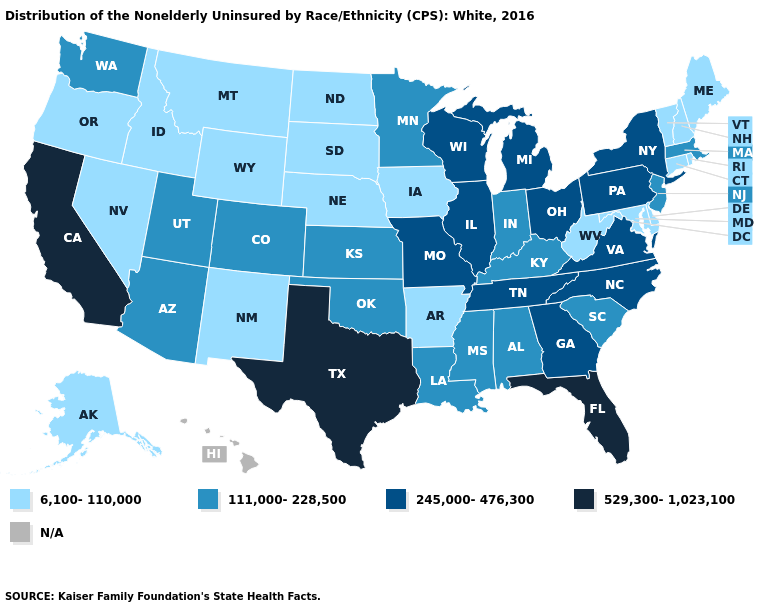What is the lowest value in the Northeast?
Give a very brief answer. 6,100-110,000. Name the states that have a value in the range 245,000-476,300?
Concise answer only. Georgia, Illinois, Michigan, Missouri, New York, North Carolina, Ohio, Pennsylvania, Tennessee, Virginia, Wisconsin. Among the states that border South Dakota , does Minnesota have the lowest value?
Give a very brief answer. No. Among the states that border Wisconsin , does Michigan have the lowest value?
Quick response, please. No. What is the value of Indiana?
Short answer required. 111,000-228,500. Does Florida have the highest value in the USA?
Keep it brief. Yes. Name the states that have a value in the range 529,300-1,023,100?
Concise answer only. California, Florida, Texas. Name the states that have a value in the range 111,000-228,500?
Keep it brief. Alabama, Arizona, Colorado, Indiana, Kansas, Kentucky, Louisiana, Massachusetts, Minnesota, Mississippi, New Jersey, Oklahoma, South Carolina, Utah, Washington. What is the highest value in the South ?
Give a very brief answer. 529,300-1,023,100. Name the states that have a value in the range 245,000-476,300?
Answer briefly. Georgia, Illinois, Michigan, Missouri, New York, North Carolina, Ohio, Pennsylvania, Tennessee, Virginia, Wisconsin. What is the value of Oklahoma?
Concise answer only. 111,000-228,500. What is the highest value in states that border Kansas?
Be succinct. 245,000-476,300. What is the highest value in states that border Arkansas?
Answer briefly. 529,300-1,023,100. What is the lowest value in the USA?
Write a very short answer. 6,100-110,000. Does Texas have the highest value in the USA?
Give a very brief answer. Yes. 